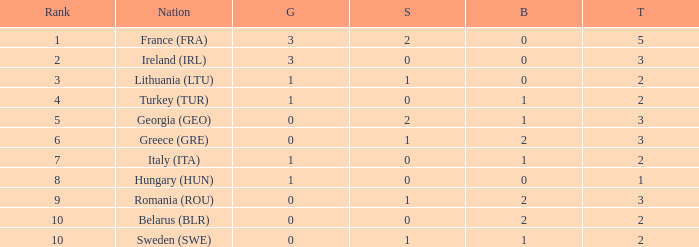What's the total of Sweden (SWE) having less than 1 silver? None. 